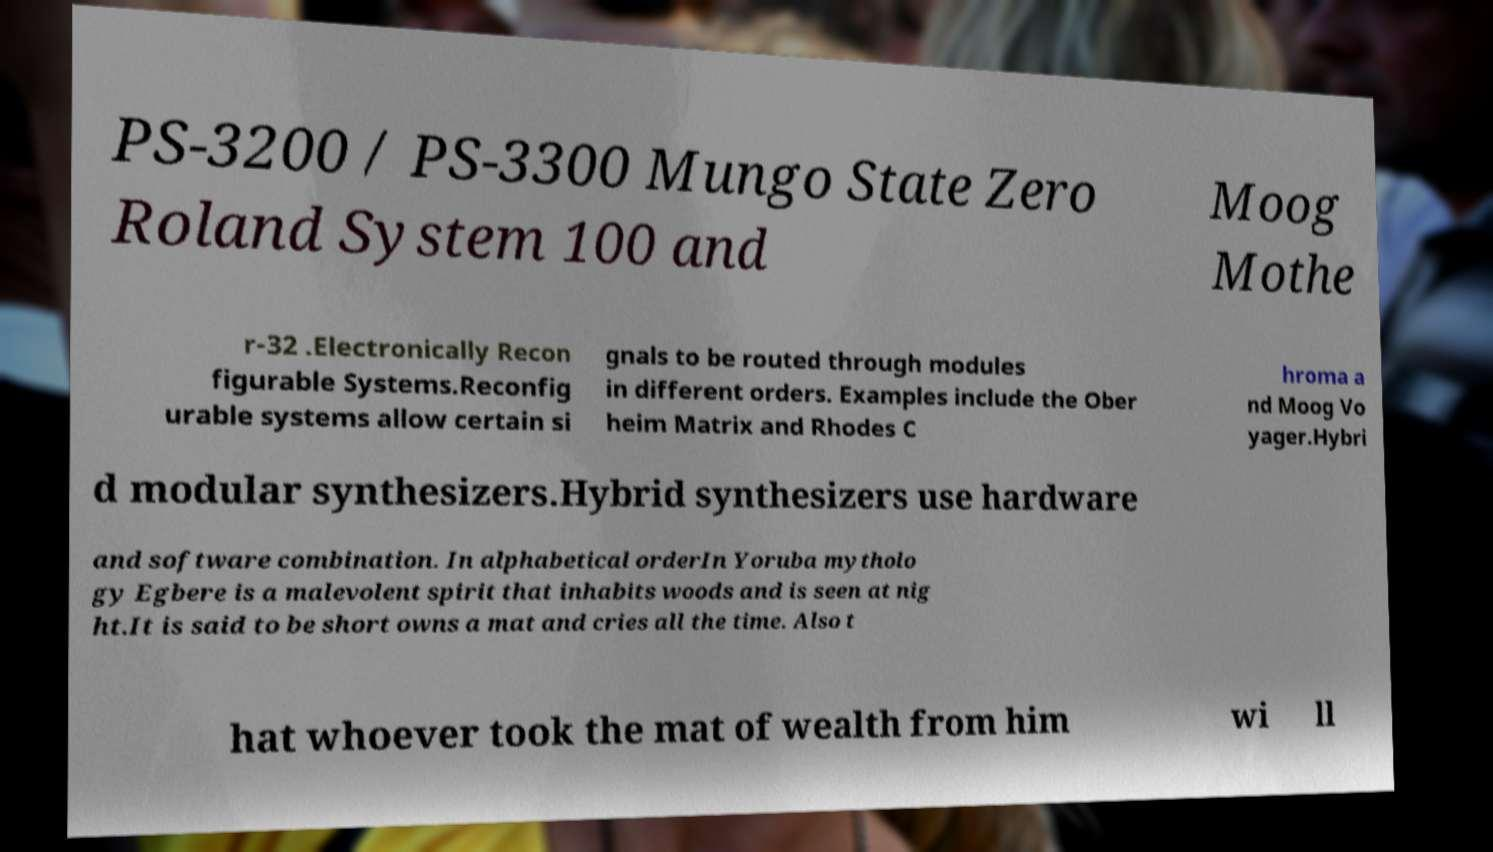Can you accurately transcribe the text from the provided image for me? PS-3200 / PS-3300 Mungo State Zero Roland System 100 and Moog Mothe r-32 .Electronically Recon figurable Systems.Reconfig urable systems allow certain si gnals to be routed through modules in different orders. Examples include the Ober heim Matrix and Rhodes C hroma a nd Moog Vo yager.Hybri d modular synthesizers.Hybrid synthesizers use hardware and software combination. In alphabetical orderIn Yoruba mytholo gy Egbere is a malevolent spirit that inhabits woods and is seen at nig ht.It is said to be short owns a mat and cries all the time. Also t hat whoever took the mat of wealth from him wi ll 